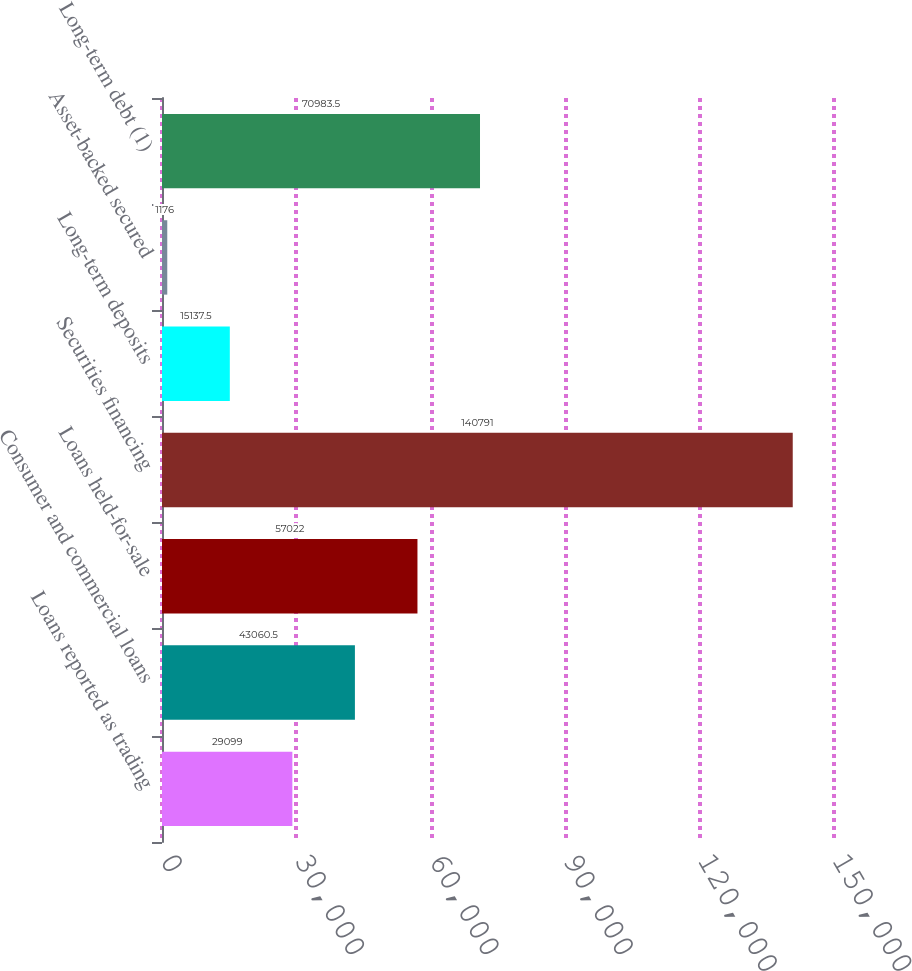<chart> <loc_0><loc_0><loc_500><loc_500><bar_chart><fcel>Loans reported as trading<fcel>Consumer and commercial loans<fcel>Loans held-for-sale<fcel>Securities financing<fcel>Long-term deposits<fcel>Asset-backed secured<fcel>Long-term debt (1)<nl><fcel>29099<fcel>43060.5<fcel>57022<fcel>140791<fcel>15137.5<fcel>1176<fcel>70983.5<nl></chart> 